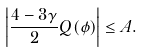Convert formula to latex. <formula><loc_0><loc_0><loc_500><loc_500>\left | \frac { 4 - 3 \gamma } { 2 } Q ( \phi ) \right | \leq A .</formula> 